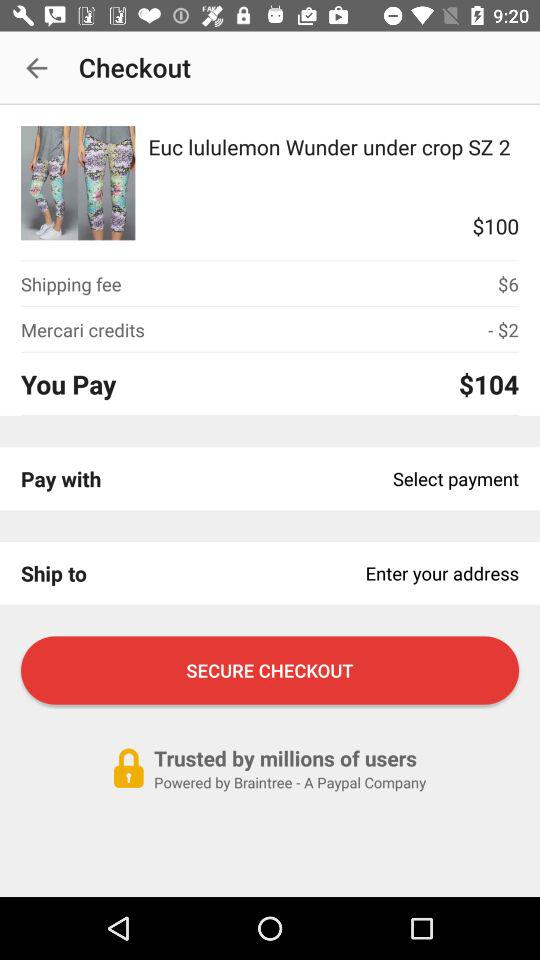By whom is the app powered? The app is powered by "Braintree". 